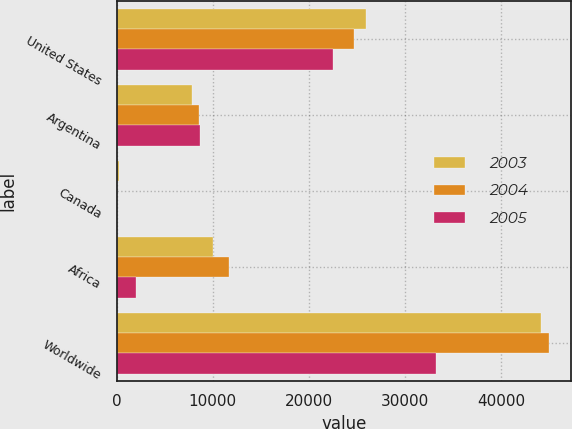Convert chart to OTSL. <chart><loc_0><loc_0><loc_500><loc_500><stacked_bar_chart><ecel><fcel>United States<fcel>Argentina<fcel>Canada<fcel>Africa<fcel>Worldwide<nl><fcel>2003<fcel>25943<fcel>7869<fcel>210<fcel>10065<fcel>44087<nl><fcel>2004<fcel>24700<fcel>8534<fcel>72<fcel>11676<fcel>44982<nl><fcel>2005<fcel>22509<fcel>8687<fcel>35<fcel>1981<fcel>33212<nl></chart> 